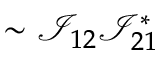<formula> <loc_0><loc_0><loc_500><loc_500>\sim \mathcal { I } _ { 1 2 } \mathcal { I } _ { 2 1 } ^ { * }</formula> 